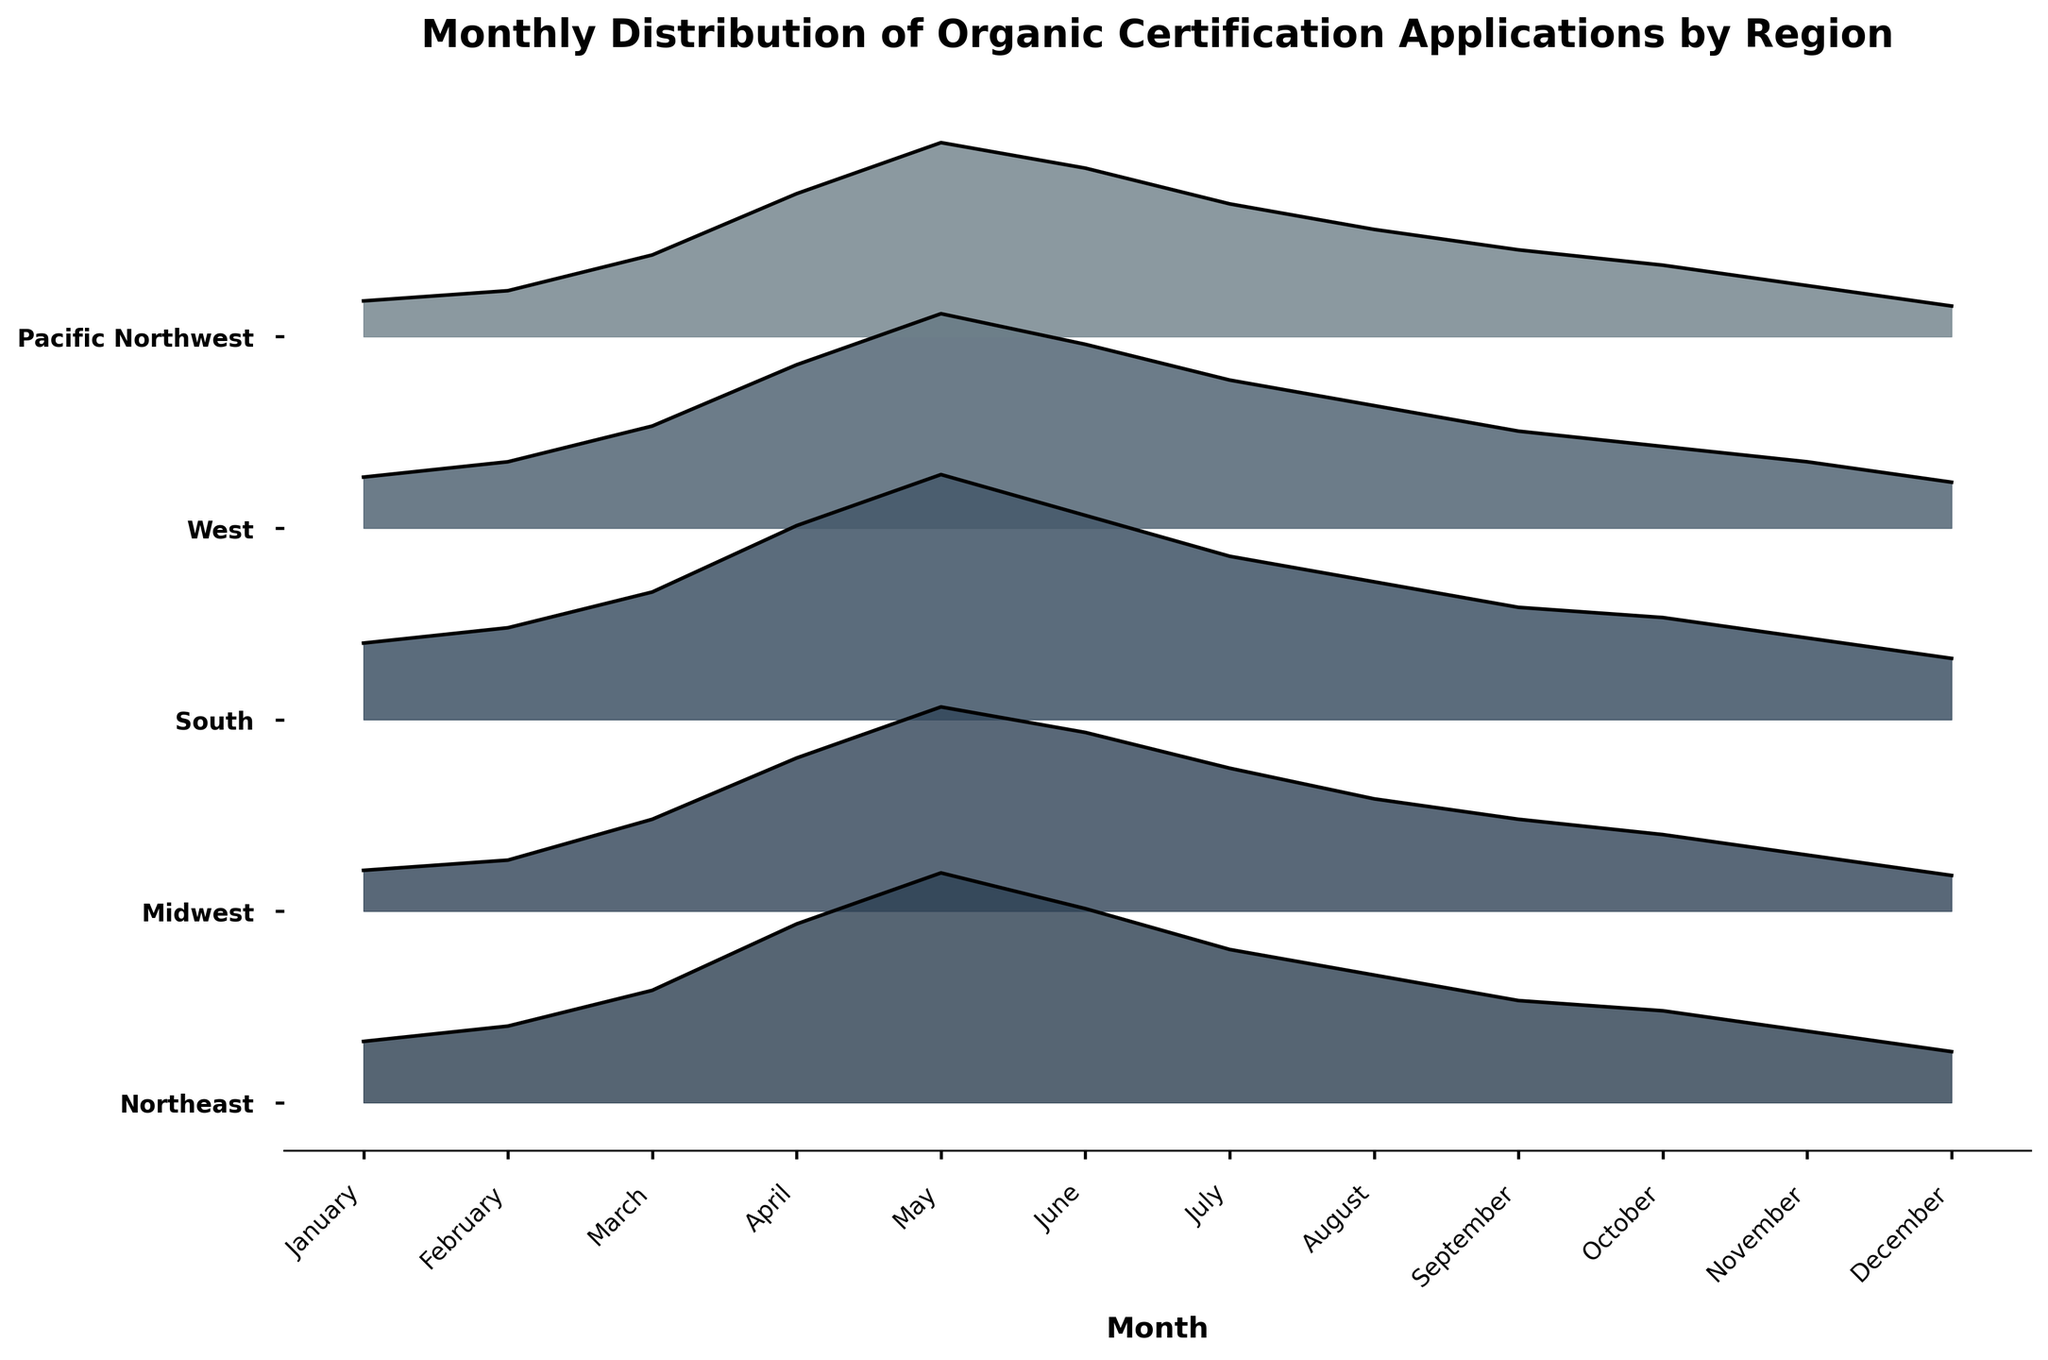what is the title of the figure? The title of a figure gives an overview of what the figure represents. The title of this figure is located at the top of the plot.
Answer: Monthly Distribution of Organic Certification Applications by Region which region has the highest application count in May? To find which region has the highest application count, locate May on the x-axis and observe the height of the ridgelines. The region with the tallest ridgeline in May represents the highest application count.
Answer: Midwest how many regions are represented in the figure? Count the number of unique labels along the y-axis of the figure. Each label represents a different region.
Answer: 5 which month has the lowest application count in the Northeast region? To identify the month with the lowest application count, look for the least elevated point on the Northeast ridgeline and correlate it with the x-axis which corresponds to the months.
Answer: December what is the general trend of application counts in the West region throughout the year? Observing the ridgeline for the West region from January to December can reveal the general pattern in applications. Noting the heights can show if they increase, decrease, or fluctuate.
Answer: Peaks in May, decreases afterward compare the application counts between February and October in the Pacific Northwest region. Which month has the higher count? Comparing the heights of the ridgeline for Pacific Northwest in February and October, the month with the taller ridgeline has a higher count.
Answer: February in which month do all the regions have their peak application counts? Examine each ridgeline and identify the month where all have their maximum values. This occurs when all the ridgelines are at their highest points for a single month.
Answer: May what is the difference in application counts between March and August for the South region? Identify the heights of the ridgelines for the South region in March and August, then calculate the difference between these application counts.
Answer: 25-27 = -2 which two regions have the closest application counts in April? Compare the heights of the ridgelines for each region in April. The regions with similar heights have the closest application counts.
Answer: West and Pacific Northwest 